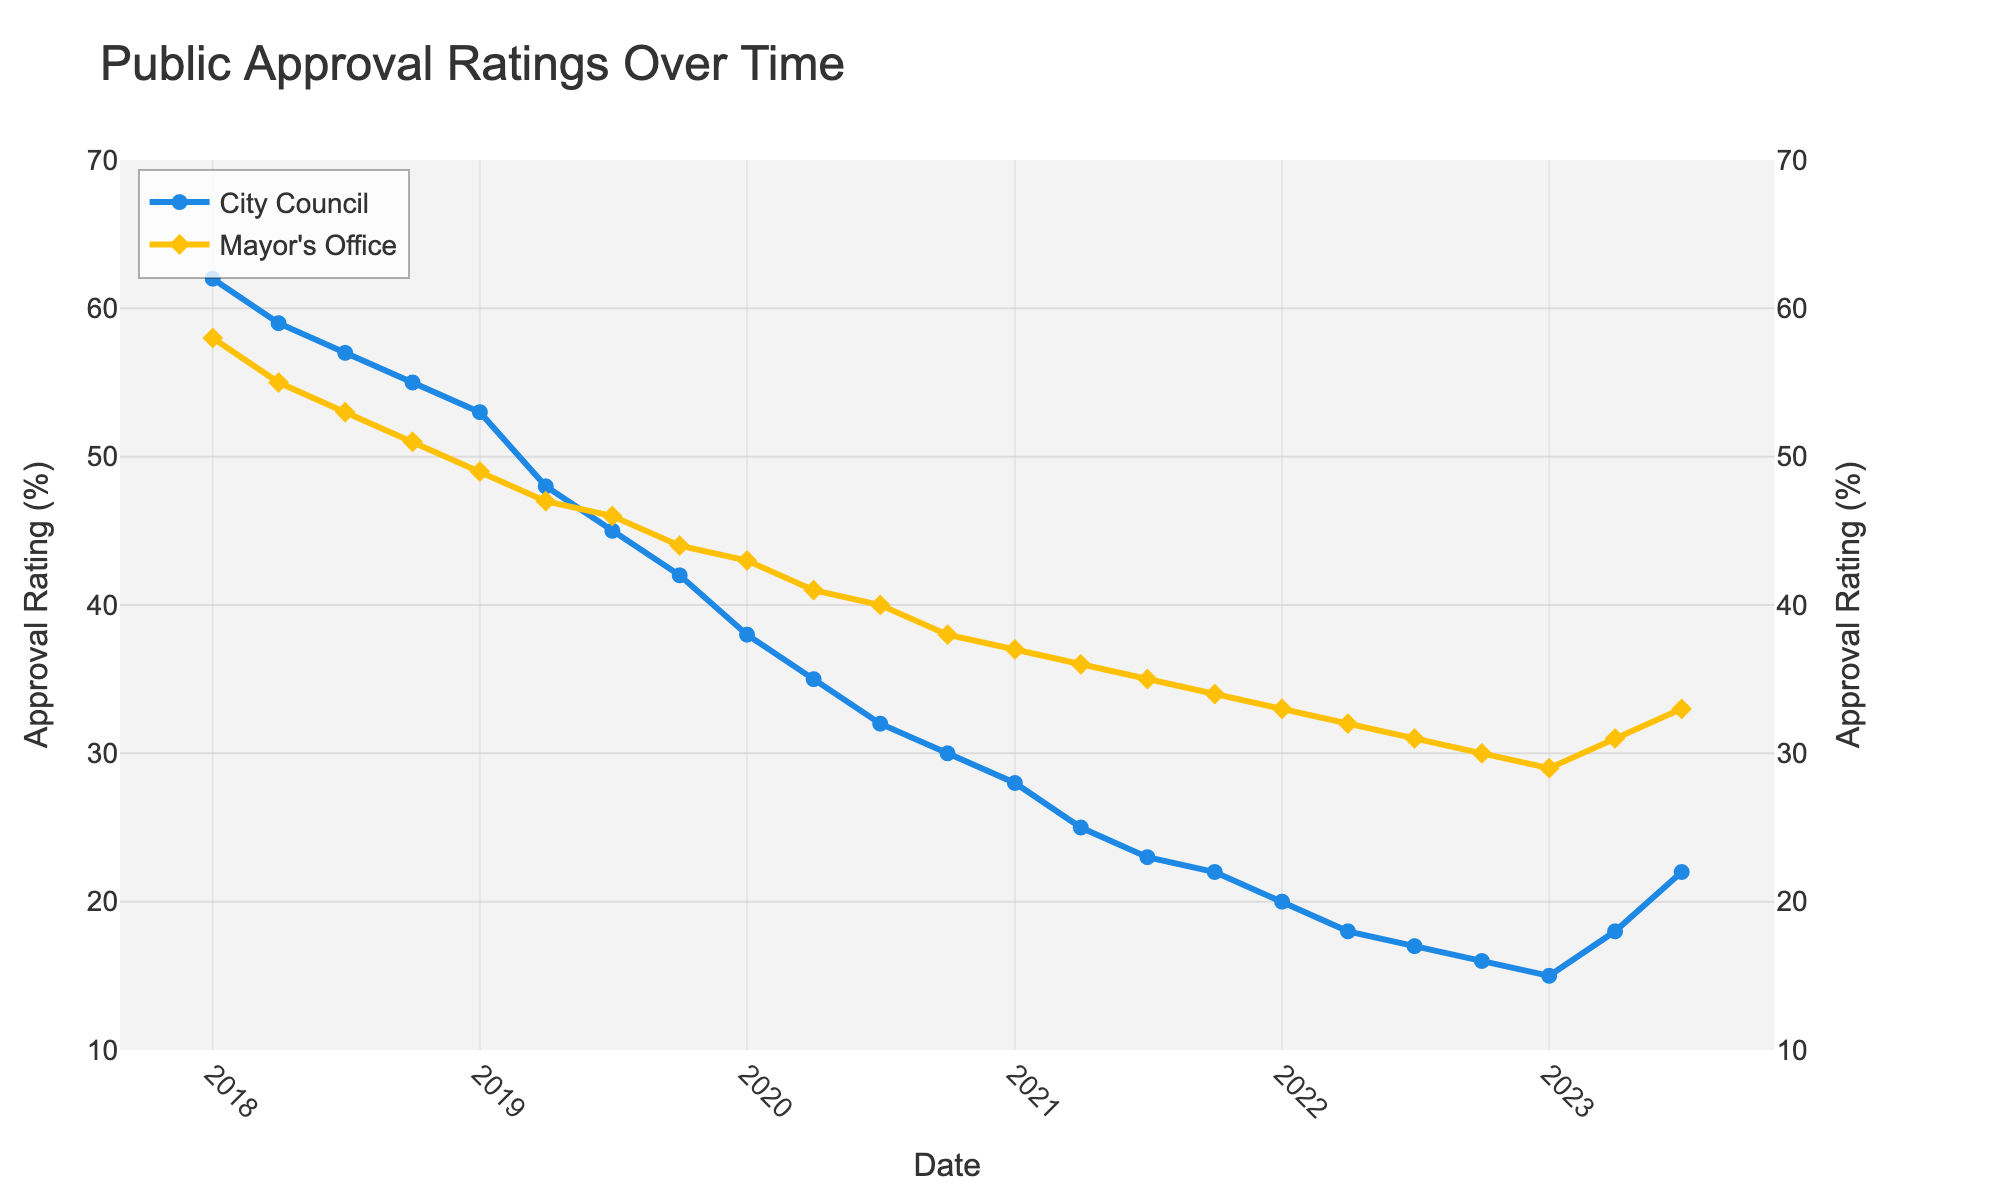What's the general trend of the city council's approval rating from 2018 to mid-2023? The city council's approval rating shows a general downward trend from 62% in January 2018 to around 22% in mid-2023.
Answer: Downward Which office has a higher approval rating in October 2020? In October 2020, the city council has an approval rating of 30% and the mayor's office has an approval rating of 38%, making the mayor's office higher.
Answer: Mayor's office Between which dates does the city council's approval rating drop the most sharply? The city council's approval rating drops sharply between October 2019 and October 2020, from 42% to 30%.
Answer: October 2019 and October 2020 What is the difference in approval ratings between the city council and the mayor's office in July 2020? In July 2020, the city council's approval rating is 32% while the mayor's office's rating is 40%. The difference is 40% - 32% = 8%.
Answer: 8% What do the symbols used in the plot represent? The symbols used in the plot represent different offices: circles for the city council and diamonds for the mayor's office.
Answer: Circles for city council, diamonds for mayor's office When do both offices show their lowest approval ratings and what are they? Both offices show their lowest approval ratings in January 2023 and April 2022, with the city council at 15% and the mayor's office at 29%.
Answer: January 2023 for city council, April 2022 for mayor's office Does the approval rating of the mayor's office ever increase while that of the city council decreases? Yes, in the period from January to April 2023, the city council rating increases from 15% to 18%, and the mayor’s office rating increases from 29% to 31%, while previously city council exhibited a downward trend.
Answer: Yes In what period do both the council and the mayor’s office show a simultaneous increase in approval ratings? Both the council and the mayor’s office show a simultaneous increase in approval ratings from January to July 2023. The council's approval goes up from 15% to 22% and the mayor's office goes up from 29% to 33%.
Answer: January to July 2023 What's the approval rating difference trend between January 2018 and January 2021? The approval rating difference between the city council and the mayor's office generally widens from a difference of 4% in January 2018 to 9% in January 2021.
Answer: Widening 